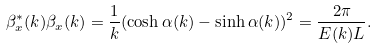<formula> <loc_0><loc_0><loc_500><loc_500>\beta _ { x } ^ { \ast } ( k ) \beta _ { x } ( k ) = \frac { 1 } { k } ( \cosh \alpha ( k ) - \sinh \alpha ( k ) ) ^ { 2 } = \frac { 2 \pi } { E ( k ) L } .</formula> 